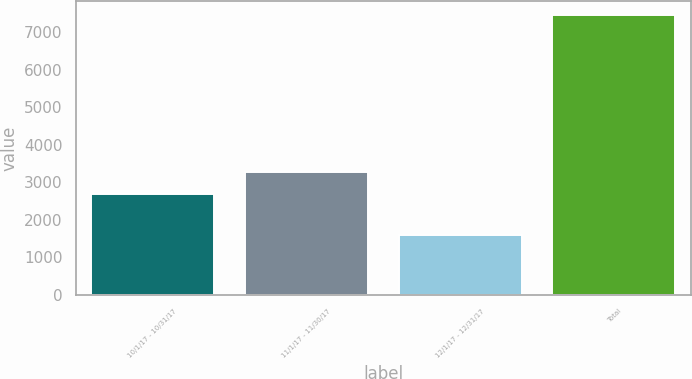Convert chart. <chart><loc_0><loc_0><loc_500><loc_500><bar_chart><fcel>10/1/17 - 10/31/17<fcel>11/1/17 - 11/30/17<fcel>12/1/17 - 12/31/17<fcel>Total<nl><fcel>2686<fcel>3270.8<fcel>1603<fcel>7451<nl></chart> 